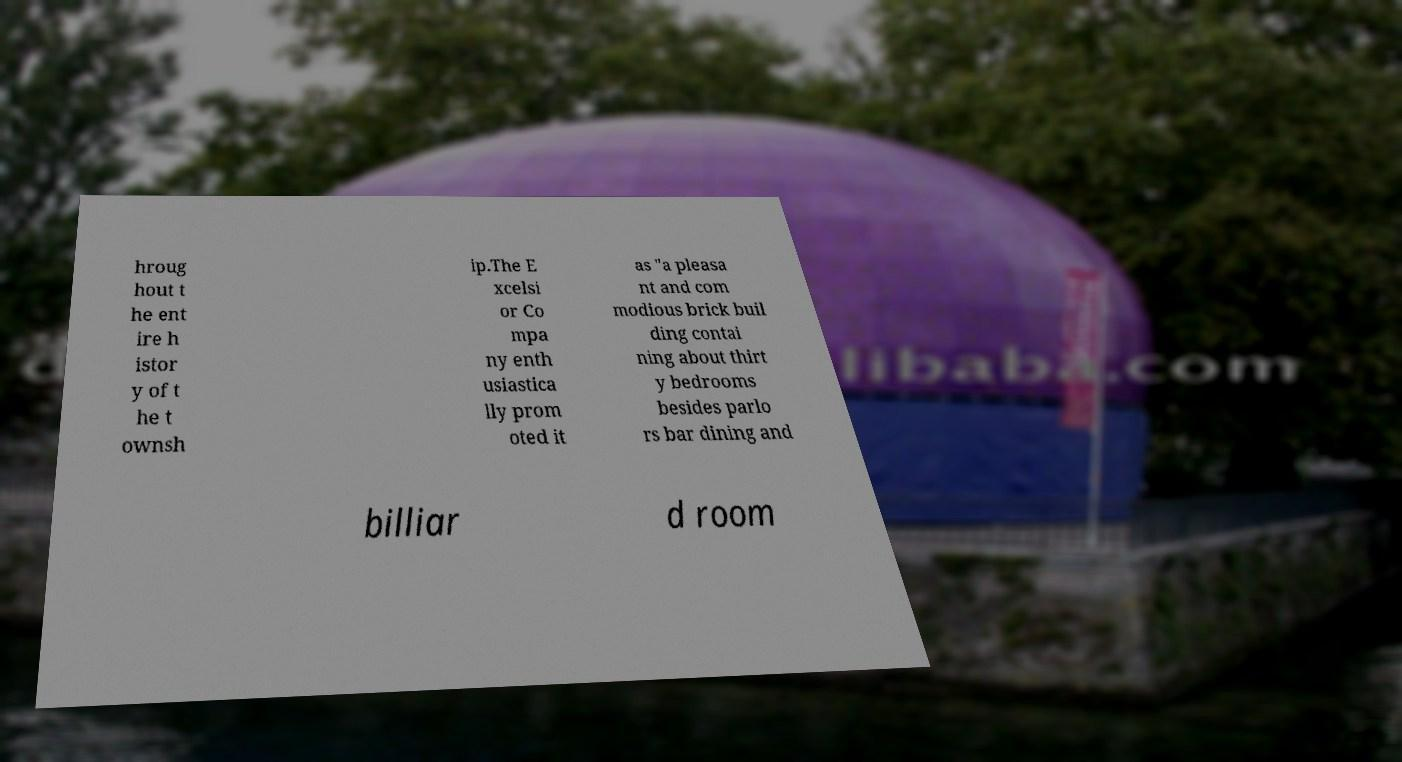Could you extract and type out the text from this image? hroug hout t he ent ire h istor y of t he t ownsh ip.The E xcelsi or Co mpa ny enth usiastica lly prom oted it as "a pleasa nt and com modious brick buil ding contai ning about thirt y bedrooms besides parlo rs bar dining and billiar d room 